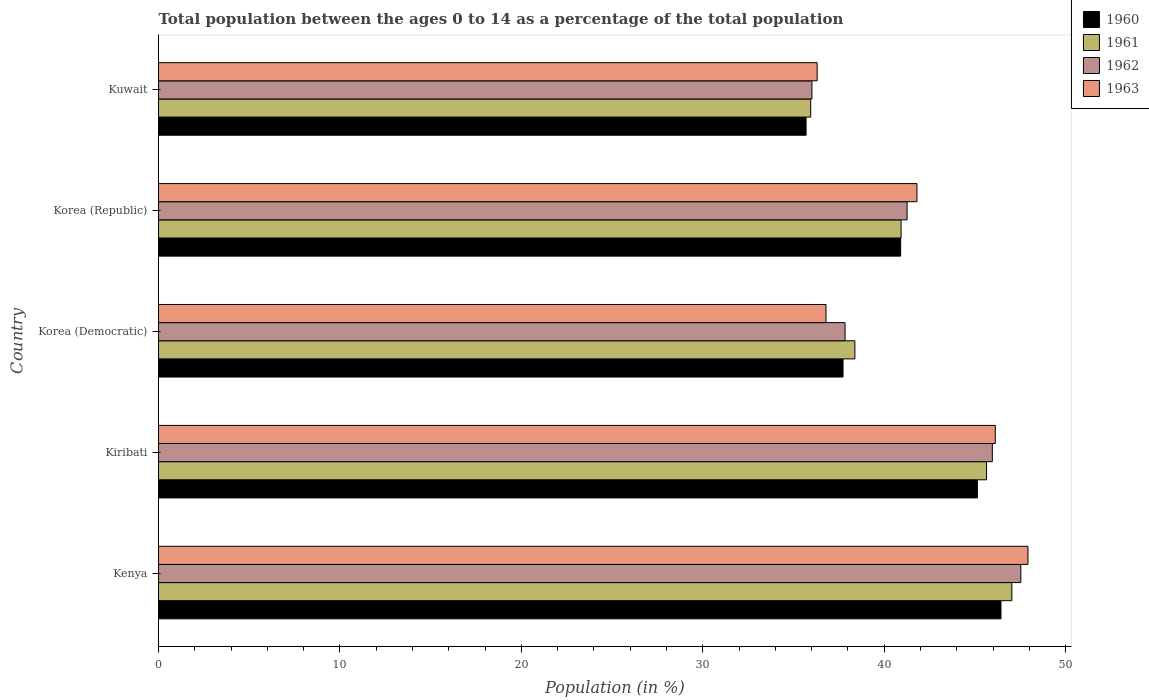How many different coloured bars are there?
Provide a succinct answer. 4. How many groups of bars are there?
Offer a very short reply. 5. How many bars are there on the 2nd tick from the bottom?
Offer a very short reply. 4. In how many cases, is the number of bars for a given country not equal to the number of legend labels?
Provide a succinct answer. 0. What is the percentage of the population ages 0 to 14 in 1961 in Kenya?
Ensure brevity in your answer.  47.04. Across all countries, what is the maximum percentage of the population ages 0 to 14 in 1962?
Give a very brief answer. 47.53. Across all countries, what is the minimum percentage of the population ages 0 to 14 in 1962?
Make the answer very short. 36.02. In which country was the percentage of the population ages 0 to 14 in 1962 maximum?
Offer a very short reply. Kenya. In which country was the percentage of the population ages 0 to 14 in 1962 minimum?
Make the answer very short. Kuwait. What is the total percentage of the population ages 0 to 14 in 1960 in the graph?
Ensure brevity in your answer.  205.91. What is the difference between the percentage of the population ages 0 to 14 in 1961 in Kenya and that in Kiribati?
Offer a very short reply. 1.39. What is the difference between the percentage of the population ages 0 to 14 in 1963 in Korea (Republic) and the percentage of the population ages 0 to 14 in 1961 in Kiribati?
Ensure brevity in your answer.  -3.84. What is the average percentage of the population ages 0 to 14 in 1962 per country?
Your answer should be very brief. 41.72. What is the difference between the percentage of the population ages 0 to 14 in 1960 and percentage of the population ages 0 to 14 in 1961 in Kiribati?
Offer a very short reply. -0.51. In how many countries, is the percentage of the population ages 0 to 14 in 1963 greater than 34 ?
Your answer should be compact. 5. What is the ratio of the percentage of the population ages 0 to 14 in 1961 in Korea (Democratic) to that in Korea (Republic)?
Ensure brevity in your answer.  0.94. Is the difference between the percentage of the population ages 0 to 14 in 1960 in Korea (Republic) and Kuwait greater than the difference between the percentage of the population ages 0 to 14 in 1961 in Korea (Republic) and Kuwait?
Provide a short and direct response. Yes. What is the difference between the highest and the second highest percentage of the population ages 0 to 14 in 1963?
Provide a succinct answer. 1.8. What is the difference between the highest and the lowest percentage of the population ages 0 to 14 in 1960?
Keep it short and to the point. 10.74. In how many countries, is the percentage of the population ages 0 to 14 in 1963 greater than the average percentage of the population ages 0 to 14 in 1963 taken over all countries?
Offer a very short reply. 3. Is the sum of the percentage of the population ages 0 to 14 in 1960 in Kenya and Korea (Republic) greater than the maximum percentage of the population ages 0 to 14 in 1963 across all countries?
Your response must be concise. Yes. Is it the case that in every country, the sum of the percentage of the population ages 0 to 14 in 1961 and percentage of the population ages 0 to 14 in 1960 is greater than the sum of percentage of the population ages 0 to 14 in 1962 and percentage of the population ages 0 to 14 in 1963?
Offer a very short reply. No. What does the 2nd bar from the top in Kiribati represents?
Offer a terse response. 1962. Is it the case that in every country, the sum of the percentage of the population ages 0 to 14 in 1960 and percentage of the population ages 0 to 14 in 1961 is greater than the percentage of the population ages 0 to 14 in 1963?
Offer a terse response. Yes. Are all the bars in the graph horizontal?
Make the answer very short. Yes. How many countries are there in the graph?
Keep it short and to the point. 5. What is the difference between two consecutive major ticks on the X-axis?
Your response must be concise. 10. Does the graph contain any zero values?
Your answer should be compact. No. Does the graph contain grids?
Offer a very short reply. No. Where does the legend appear in the graph?
Provide a succinct answer. Top right. What is the title of the graph?
Keep it short and to the point. Total population between the ages 0 to 14 as a percentage of the total population. What is the label or title of the X-axis?
Your answer should be compact. Population (in %). What is the label or title of the Y-axis?
Offer a very short reply. Country. What is the Population (in %) of 1960 in Kenya?
Your response must be concise. 46.44. What is the Population (in %) of 1961 in Kenya?
Make the answer very short. 47.04. What is the Population (in %) of 1962 in Kenya?
Make the answer very short. 47.53. What is the Population (in %) in 1963 in Kenya?
Keep it short and to the point. 47.93. What is the Population (in %) of 1960 in Kiribati?
Your response must be concise. 45.14. What is the Population (in %) of 1961 in Kiribati?
Provide a short and direct response. 45.64. What is the Population (in %) of 1962 in Kiribati?
Give a very brief answer. 45.96. What is the Population (in %) in 1963 in Kiribati?
Your answer should be very brief. 46.12. What is the Population (in %) in 1960 in Korea (Democratic)?
Give a very brief answer. 37.73. What is the Population (in %) in 1961 in Korea (Democratic)?
Keep it short and to the point. 38.39. What is the Population (in %) in 1962 in Korea (Democratic)?
Offer a very short reply. 37.84. What is the Population (in %) of 1963 in Korea (Democratic)?
Ensure brevity in your answer.  36.79. What is the Population (in %) of 1960 in Korea (Republic)?
Your answer should be compact. 40.91. What is the Population (in %) of 1961 in Korea (Republic)?
Keep it short and to the point. 40.93. What is the Population (in %) in 1962 in Korea (Republic)?
Your response must be concise. 41.26. What is the Population (in %) of 1963 in Korea (Republic)?
Provide a succinct answer. 41.81. What is the Population (in %) of 1960 in Kuwait?
Offer a very short reply. 35.7. What is the Population (in %) of 1961 in Kuwait?
Your answer should be very brief. 35.95. What is the Population (in %) of 1962 in Kuwait?
Your response must be concise. 36.02. What is the Population (in %) of 1963 in Kuwait?
Make the answer very short. 36.31. Across all countries, what is the maximum Population (in %) in 1960?
Ensure brevity in your answer.  46.44. Across all countries, what is the maximum Population (in %) in 1961?
Ensure brevity in your answer.  47.04. Across all countries, what is the maximum Population (in %) of 1962?
Offer a terse response. 47.53. Across all countries, what is the maximum Population (in %) of 1963?
Ensure brevity in your answer.  47.93. Across all countries, what is the minimum Population (in %) in 1960?
Offer a very short reply. 35.7. Across all countries, what is the minimum Population (in %) of 1961?
Provide a succinct answer. 35.95. Across all countries, what is the minimum Population (in %) of 1962?
Keep it short and to the point. 36.02. Across all countries, what is the minimum Population (in %) of 1963?
Your response must be concise. 36.31. What is the total Population (in %) in 1960 in the graph?
Keep it short and to the point. 205.91. What is the total Population (in %) of 1961 in the graph?
Ensure brevity in your answer.  207.95. What is the total Population (in %) of 1962 in the graph?
Ensure brevity in your answer.  208.62. What is the total Population (in %) of 1963 in the graph?
Keep it short and to the point. 208.95. What is the difference between the Population (in %) in 1960 in Kenya and that in Kiribati?
Your answer should be very brief. 1.3. What is the difference between the Population (in %) in 1961 in Kenya and that in Kiribati?
Your answer should be very brief. 1.39. What is the difference between the Population (in %) in 1962 in Kenya and that in Kiribati?
Ensure brevity in your answer.  1.57. What is the difference between the Population (in %) of 1963 in Kenya and that in Kiribati?
Your answer should be very brief. 1.8. What is the difference between the Population (in %) in 1960 in Kenya and that in Korea (Democratic)?
Your answer should be very brief. 8.71. What is the difference between the Population (in %) in 1961 in Kenya and that in Korea (Democratic)?
Offer a very short reply. 8.65. What is the difference between the Population (in %) in 1962 in Kenya and that in Korea (Democratic)?
Provide a short and direct response. 9.69. What is the difference between the Population (in %) in 1963 in Kenya and that in Korea (Democratic)?
Your answer should be compact. 11.13. What is the difference between the Population (in %) in 1960 in Kenya and that in Korea (Republic)?
Give a very brief answer. 5.53. What is the difference between the Population (in %) of 1961 in Kenya and that in Korea (Republic)?
Make the answer very short. 6.1. What is the difference between the Population (in %) of 1962 in Kenya and that in Korea (Republic)?
Offer a terse response. 6.27. What is the difference between the Population (in %) in 1963 in Kenya and that in Korea (Republic)?
Ensure brevity in your answer.  6.12. What is the difference between the Population (in %) in 1960 in Kenya and that in Kuwait?
Offer a very short reply. 10.74. What is the difference between the Population (in %) of 1961 in Kenya and that in Kuwait?
Provide a succinct answer. 11.09. What is the difference between the Population (in %) in 1962 in Kenya and that in Kuwait?
Your answer should be compact. 11.52. What is the difference between the Population (in %) of 1963 in Kenya and that in Kuwait?
Your answer should be very brief. 11.62. What is the difference between the Population (in %) of 1960 in Kiribati and that in Korea (Democratic)?
Offer a very short reply. 7.4. What is the difference between the Population (in %) in 1961 in Kiribati and that in Korea (Democratic)?
Offer a very short reply. 7.26. What is the difference between the Population (in %) in 1962 in Kiribati and that in Korea (Democratic)?
Your answer should be compact. 8.12. What is the difference between the Population (in %) of 1963 in Kiribati and that in Korea (Democratic)?
Provide a succinct answer. 9.33. What is the difference between the Population (in %) in 1960 in Kiribati and that in Korea (Republic)?
Offer a very short reply. 4.23. What is the difference between the Population (in %) in 1961 in Kiribati and that in Korea (Republic)?
Your response must be concise. 4.71. What is the difference between the Population (in %) in 1962 in Kiribati and that in Korea (Republic)?
Make the answer very short. 4.7. What is the difference between the Population (in %) in 1963 in Kiribati and that in Korea (Republic)?
Provide a succinct answer. 4.32. What is the difference between the Population (in %) of 1960 in Kiribati and that in Kuwait?
Your answer should be very brief. 9.44. What is the difference between the Population (in %) of 1961 in Kiribati and that in Kuwait?
Offer a very short reply. 9.69. What is the difference between the Population (in %) of 1962 in Kiribati and that in Kuwait?
Your response must be concise. 9.94. What is the difference between the Population (in %) in 1963 in Kiribati and that in Kuwait?
Provide a short and direct response. 9.82. What is the difference between the Population (in %) in 1960 in Korea (Democratic) and that in Korea (Republic)?
Your answer should be compact. -3.17. What is the difference between the Population (in %) of 1961 in Korea (Democratic) and that in Korea (Republic)?
Your response must be concise. -2.55. What is the difference between the Population (in %) of 1962 in Korea (Democratic) and that in Korea (Republic)?
Your response must be concise. -3.42. What is the difference between the Population (in %) of 1963 in Korea (Democratic) and that in Korea (Republic)?
Provide a short and direct response. -5.01. What is the difference between the Population (in %) of 1960 in Korea (Democratic) and that in Kuwait?
Provide a short and direct response. 2.04. What is the difference between the Population (in %) in 1961 in Korea (Democratic) and that in Kuwait?
Your response must be concise. 2.44. What is the difference between the Population (in %) in 1962 in Korea (Democratic) and that in Kuwait?
Your answer should be very brief. 1.83. What is the difference between the Population (in %) in 1963 in Korea (Democratic) and that in Kuwait?
Give a very brief answer. 0.49. What is the difference between the Population (in %) of 1960 in Korea (Republic) and that in Kuwait?
Give a very brief answer. 5.21. What is the difference between the Population (in %) in 1961 in Korea (Republic) and that in Kuwait?
Your answer should be very brief. 4.98. What is the difference between the Population (in %) of 1962 in Korea (Republic) and that in Kuwait?
Provide a short and direct response. 5.25. What is the difference between the Population (in %) in 1963 in Korea (Republic) and that in Kuwait?
Give a very brief answer. 5.5. What is the difference between the Population (in %) in 1960 in Kenya and the Population (in %) in 1961 in Kiribati?
Offer a terse response. 0.8. What is the difference between the Population (in %) of 1960 in Kenya and the Population (in %) of 1962 in Kiribati?
Provide a succinct answer. 0.48. What is the difference between the Population (in %) in 1960 in Kenya and the Population (in %) in 1963 in Kiribati?
Keep it short and to the point. 0.31. What is the difference between the Population (in %) in 1961 in Kenya and the Population (in %) in 1962 in Kiribati?
Keep it short and to the point. 1.07. What is the difference between the Population (in %) of 1961 in Kenya and the Population (in %) of 1963 in Kiribati?
Your answer should be compact. 0.91. What is the difference between the Population (in %) in 1962 in Kenya and the Population (in %) in 1963 in Kiribati?
Provide a succinct answer. 1.41. What is the difference between the Population (in %) in 1960 in Kenya and the Population (in %) in 1961 in Korea (Democratic)?
Provide a short and direct response. 8.05. What is the difference between the Population (in %) in 1960 in Kenya and the Population (in %) in 1962 in Korea (Democratic)?
Make the answer very short. 8.6. What is the difference between the Population (in %) of 1960 in Kenya and the Population (in %) of 1963 in Korea (Democratic)?
Offer a very short reply. 9.65. What is the difference between the Population (in %) in 1961 in Kenya and the Population (in %) in 1962 in Korea (Democratic)?
Make the answer very short. 9.19. What is the difference between the Population (in %) in 1961 in Kenya and the Population (in %) in 1963 in Korea (Democratic)?
Provide a short and direct response. 10.24. What is the difference between the Population (in %) in 1962 in Kenya and the Population (in %) in 1963 in Korea (Democratic)?
Your answer should be very brief. 10.74. What is the difference between the Population (in %) in 1960 in Kenya and the Population (in %) in 1961 in Korea (Republic)?
Provide a succinct answer. 5.51. What is the difference between the Population (in %) of 1960 in Kenya and the Population (in %) of 1962 in Korea (Republic)?
Your answer should be compact. 5.18. What is the difference between the Population (in %) of 1960 in Kenya and the Population (in %) of 1963 in Korea (Republic)?
Offer a terse response. 4.63. What is the difference between the Population (in %) of 1961 in Kenya and the Population (in %) of 1962 in Korea (Republic)?
Keep it short and to the point. 5.77. What is the difference between the Population (in %) in 1961 in Kenya and the Population (in %) in 1963 in Korea (Republic)?
Your response must be concise. 5.23. What is the difference between the Population (in %) of 1962 in Kenya and the Population (in %) of 1963 in Korea (Republic)?
Provide a short and direct response. 5.73. What is the difference between the Population (in %) of 1960 in Kenya and the Population (in %) of 1961 in Kuwait?
Your answer should be very brief. 10.49. What is the difference between the Population (in %) of 1960 in Kenya and the Population (in %) of 1962 in Kuwait?
Your answer should be compact. 10.42. What is the difference between the Population (in %) in 1960 in Kenya and the Population (in %) in 1963 in Kuwait?
Keep it short and to the point. 10.13. What is the difference between the Population (in %) of 1961 in Kenya and the Population (in %) of 1962 in Kuwait?
Offer a very short reply. 11.02. What is the difference between the Population (in %) in 1961 in Kenya and the Population (in %) in 1963 in Kuwait?
Make the answer very short. 10.73. What is the difference between the Population (in %) in 1962 in Kenya and the Population (in %) in 1963 in Kuwait?
Your answer should be very brief. 11.23. What is the difference between the Population (in %) in 1960 in Kiribati and the Population (in %) in 1961 in Korea (Democratic)?
Give a very brief answer. 6.75. What is the difference between the Population (in %) of 1960 in Kiribati and the Population (in %) of 1962 in Korea (Democratic)?
Ensure brevity in your answer.  7.29. What is the difference between the Population (in %) of 1960 in Kiribati and the Population (in %) of 1963 in Korea (Democratic)?
Keep it short and to the point. 8.34. What is the difference between the Population (in %) of 1961 in Kiribati and the Population (in %) of 1962 in Korea (Democratic)?
Your answer should be compact. 7.8. What is the difference between the Population (in %) in 1961 in Kiribati and the Population (in %) in 1963 in Korea (Democratic)?
Provide a succinct answer. 8.85. What is the difference between the Population (in %) of 1962 in Kiribati and the Population (in %) of 1963 in Korea (Democratic)?
Provide a short and direct response. 9.17. What is the difference between the Population (in %) in 1960 in Kiribati and the Population (in %) in 1961 in Korea (Republic)?
Give a very brief answer. 4.21. What is the difference between the Population (in %) in 1960 in Kiribati and the Population (in %) in 1962 in Korea (Republic)?
Offer a very short reply. 3.87. What is the difference between the Population (in %) in 1960 in Kiribati and the Population (in %) in 1963 in Korea (Republic)?
Provide a succinct answer. 3.33. What is the difference between the Population (in %) in 1961 in Kiribati and the Population (in %) in 1962 in Korea (Republic)?
Your answer should be very brief. 4.38. What is the difference between the Population (in %) in 1961 in Kiribati and the Population (in %) in 1963 in Korea (Republic)?
Keep it short and to the point. 3.84. What is the difference between the Population (in %) in 1962 in Kiribati and the Population (in %) in 1963 in Korea (Republic)?
Offer a very short reply. 4.15. What is the difference between the Population (in %) in 1960 in Kiribati and the Population (in %) in 1961 in Kuwait?
Offer a terse response. 9.19. What is the difference between the Population (in %) of 1960 in Kiribati and the Population (in %) of 1962 in Kuwait?
Offer a very short reply. 9.12. What is the difference between the Population (in %) in 1960 in Kiribati and the Population (in %) in 1963 in Kuwait?
Ensure brevity in your answer.  8.83. What is the difference between the Population (in %) of 1961 in Kiribati and the Population (in %) of 1962 in Kuwait?
Provide a short and direct response. 9.63. What is the difference between the Population (in %) of 1961 in Kiribati and the Population (in %) of 1963 in Kuwait?
Keep it short and to the point. 9.34. What is the difference between the Population (in %) of 1962 in Kiribati and the Population (in %) of 1963 in Kuwait?
Your answer should be compact. 9.66. What is the difference between the Population (in %) of 1960 in Korea (Democratic) and the Population (in %) of 1961 in Korea (Republic)?
Make the answer very short. -3.2. What is the difference between the Population (in %) of 1960 in Korea (Democratic) and the Population (in %) of 1962 in Korea (Republic)?
Your response must be concise. -3.53. What is the difference between the Population (in %) of 1960 in Korea (Democratic) and the Population (in %) of 1963 in Korea (Republic)?
Your answer should be compact. -4.07. What is the difference between the Population (in %) of 1961 in Korea (Democratic) and the Population (in %) of 1962 in Korea (Republic)?
Provide a short and direct response. -2.88. What is the difference between the Population (in %) in 1961 in Korea (Democratic) and the Population (in %) in 1963 in Korea (Republic)?
Keep it short and to the point. -3.42. What is the difference between the Population (in %) of 1962 in Korea (Democratic) and the Population (in %) of 1963 in Korea (Republic)?
Your answer should be very brief. -3.96. What is the difference between the Population (in %) of 1960 in Korea (Democratic) and the Population (in %) of 1961 in Kuwait?
Make the answer very short. 1.78. What is the difference between the Population (in %) in 1960 in Korea (Democratic) and the Population (in %) in 1962 in Kuwait?
Provide a short and direct response. 1.72. What is the difference between the Population (in %) of 1960 in Korea (Democratic) and the Population (in %) of 1963 in Kuwait?
Your answer should be very brief. 1.43. What is the difference between the Population (in %) of 1961 in Korea (Democratic) and the Population (in %) of 1962 in Kuwait?
Offer a terse response. 2.37. What is the difference between the Population (in %) of 1961 in Korea (Democratic) and the Population (in %) of 1963 in Kuwait?
Provide a short and direct response. 2.08. What is the difference between the Population (in %) in 1962 in Korea (Democratic) and the Population (in %) in 1963 in Kuwait?
Make the answer very short. 1.54. What is the difference between the Population (in %) in 1960 in Korea (Republic) and the Population (in %) in 1961 in Kuwait?
Your answer should be compact. 4.96. What is the difference between the Population (in %) of 1960 in Korea (Republic) and the Population (in %) of 1962 in Kuwait?
Provide a succinct answer. 4.89. What is the difference between the Population (in %) of 1960 in Korea (Republic) and the Population (in %) of 1963 in Kuwait?
Your answer should be very brief. 4.6. What is the difference between the Population (in %) in 1961 in Korea (Republic) and the Population (in %) in 1962 in Kuwait?
Offer a very short reply. 4.92. What is the difference between the Population (in %) in 1961 in Korea (Republic) and the Population (in %) in 1963 in Kuwait?
Make the answer very short. 4.63. What is the difference between the Population (in %) in 1962 in Korea (Republic) and the Population (in %) in 1963 in Kuwait?
Your answer should be very brief. 4.96. What is the average Population (in %) of 1960 per country?
Make the answer very short. 41.18. What is the average Population (in %) of 1961 per country?
Offer a very short reply. 41.59. What is the average Population (in %) of 1962 per country?
Make the answer very short. 41.72. What is the average Population (in %) in 1963 per country?
Provide a short and direct response. 41.79. What is the difference between the Population (in %) in 1960 and Population (in %) in 1961 in Kenya?
Keep it short and to the point. -0.6. What is the difference between the Population (in %) in 1960 and Population (in %) in 1962 in Kenya?
Offer a very short reply. -1.09. What is the difference between the Population (in %) in 1960 and Population (in %) in 1963 in Kenya?
Offer a very short reply. -1.49. What is the difference between the Population (in %) of 1961 and Population (in %) of 1962 in Kenya?
Offer a terse response. -0.5. What is the difference between the Population (in %) of 1961 and Population (in %) of 1963 in Kenya?
Give a very brief answer. -0.89. What is the difference between the Population (in %) of 1962 and Population (in %) of 1963 in Kenya?
Your response must be concise. -0.39. What is the difference between the Population (in %) in 1960 and Population (in %) in 1961 in Kiribati?
Your answer should be compact. -0.51. What is the difference between the Population (in %) of 1960 and Population (in %) of 1962 in Kiribati?
Your answer should be compact. -0.82. What is the difference between the Population (in %) of 1960 and Population (in %) of 1963 in Kiribati?
Ensure brevity in your answer.  -0.99. What is the difference between the Population (in %) of 1961 and Population (in %) of 1962 in Kiribati?
Offer a very short reply. -0.32. What is the difference between the Population (in %) of 1961 and Population (in %) of 1963 in Kiribati?
Make the answer very short. -0.48. What is the difference between the Population (in %) in 1962 and Population (in %) in 1963 in Kiribati?
Ensure brevity in your answer.  -0.16. What is the difference between the Population (in %) of 1960 and Population (in %) of 1961 in Korea (Democratic)?
Provide a succinct answer. -0.65. What is the difference between the Population (in %) in 1960 and Population (in %) in 1962 in Korea (Democratic)?
Make the answer very short. -0.11. What is the difference between the Population (in %) in 1960 and Population (in %) in 1963 in Korea (Democratic)?
Ensure brevity in your answer.  0.94. What is the difference between the Population (in %) of 1961 and Population (in %) of 1962 in Korea (Democratic)?
Ensure brevity in your answer.  0.54. What is the difference between the Population (in %) in 1961 and Population (in %) in 1963 in Korea (Democratic)?
Make the answer very short. 1.59. What is the difference between the Population (in %) of 1962 and Population (in %) of 1963 in Korea (Democratic)?
Offer a terse response. 1.05. What is the difference between the Population (in %) in 1960 and Population (in %) in 1961 in Korea (Republic)?
Your answer should be compact. -0.02. What is the difference between the Population (in %) of 1960 and Population (in %) of 1962 in Korea (Republic)?
Your answer should be very brief. -0.36. What is the difference between the Population (in %) in 1960 and Population (in %) in 1963 in Korea (Republic)?
Offer a very short reply. -0.9. What is the difference between the Population (in %) in 1961 and Population (in %) in 1962 in Korea (Republic)?
Offer a very short reply. -0.33. What is the difference between the Population (in %) of 1961 and Population (in %) of 1963 in Korea (Republic)?
Make the answer very short. -0.88. What is the difference between the Population (in %) of 1962 and Population (in %) of 1963 in Korea (Republic)?
Your answer should be compact. -0.54. What is the difference between the Population (in %) of 1960 and Population (in %) of 1961 in Kuwait?
Make the answer very short. -0.25. What is the difference between the Population (in %) of 1960 and Population (in %) of 1962 in Kuwait?
Keep it short and to the point. -0.32. What is the difference between the Population (in %) in 1960 and Population (in %) in 1963 in Kuwait?
Offer a terse response. -0.61. What is the difference between the Population (in %) of 1961 and Population (in %) of 1962 in Kuwait?
Offer a terse response. -0.07. What is the difference between the Population (in %) of 1961 and Population (in %) of 1963 in Kuwait?
Provide a short and direct response. -0.36. What is the difference between the Population (in %) in 1962 and Population (in %) in 1963 in Kuwait?
Provide a succinct answer. -0.29. What is the ratio of the Population (in %) in 1960 in Kenya to that in Kiribati?
Provide a succinct answer. 1.03. What is the ratio of the Population (in %) in 1961 in Kenya to that in Kiribati?
Your answer should be very brief. 1.03. What is the ratio of the Population (in %) of 1962 in Kenya to that in Kiribati?
Provide a short and direct response. 1.03. What is the ratio of the Population (in %) of 1963 in Kenya to that in Kiribati?
Give a very brief answer. 1.04. What is the ratio of the Population (in %) in 1960 in Kenya to that in Korea (Democratic)?
Your answer should be compact. 1.23. What is the ratio of the Population (in %) of 1961 in Kenya to that in Korea (Democratic)?
Your response must be concise. 1.23. What is the ratio of the Population (in %) of 1962 in Kenya to that in Korea (Democratic)?
Provide a succinct answer. 1.26. What is the ratio of the Population (in %) of 1963 in Kenya to that in Korea (Democratic)?
Provide a succinct answer. 1.3. What is the ratio of the Population (in %) in 1960 in Kenya to that in Korea (Republic)?
Make the answer very short. 1.14. What is the ratio of the Population (in %) of 1961 in Kenya to that in Korea (Republic)?
Give a very brief answer. 1.15. What is the ratio of the Population (in %) in 1962 in Kenya to that in Korea (Republic)?
Your response must be concise. 1.15. What is the ratio of the Population (in %) in 1963 in Kenya to that in Korea (Republic)?
Your answer should be very brief. 1.15. What is the ratio of the Population (in %) in 1960 in Kenya to that in Kuwait?
Your answer should be compact. 1.3. What is the ratio of the Population (in %) of 1961 in Kenya to that in Kuwait?
Offer a very short reply. 1.31. What is the ratio of the Population (in %) in 1962 in Kenya to that in Kuwait?
Offer a terse response. 1.32. What is the ratio of the Population (in %) in 1963 in Kenya to that in Kuwait?
Your response must be concise. 1.32. What is the ratio of the Population (in %) in 1960 in Kiribati to that in Korea (Democratic)?
Your answer should be compact. 1.2. What is the ratio of the Population (in %) in 1961 in Kiribati to that in Korea (Democratic)?
Offer a terse response. 1.19. What is the ratio of the Population (in %) in 1962 in Kiribati to that in Korea (Democratic)?
Your answer should be compact. 1.21. What is the ratio of the Population (in %) of 1963 in Kiribati to that in Korea (Democratic)?
Provide a short and direct response. 1.25. What is the ratio of the Population (in %) of 1960 in Kiribati to that in Korea (Republic)?
Make the answer very short. 1.1. What is the ratio of the Population (in %) of 1961 in Kiribati to that in Korea (Republic)?
Make the answer very short. 1.12. What is the ratio of the Population (in %) in 1962 in Kiribati to that in Korea (Republic)?
Your answer should be compact. 1.11. What is the ratio of the Population (in %) in 1963 in Kiribati to that in Korea (Republic)?
Your response must be concise. 1.1. What is the ratio of the Population (in %) in 1960 in Kiribati to that in Kuwait?
Provide a succinct answer. 1.26. What is the ratio of the Population (in %) in 1961 in Kiribati to that in Kuwait?
Provide a short and direct response. 1.27. What is the ratio of the Population (in %) in 1962 in Kiribati to that in Kuwait?
Offer a terse response. 1.28. What is the ratio of the Population (in %) of 1963 in Kiribati to that in Kuwait?
Give a very brief answer. 1.27. What is the ratio of the Population (in %) in 1960 in Korea (Democratic) to that in Korea (Republic)?
Give a very brief answer. 0.92. What is the ratio of the Population (in %) in 1961 in Korea (Democratic) to that in Korea (Republic)?
Offer a very short reply. 0.94. What is the ratio of the Population (in %) of 1962 in Korea (Democratic) to that in Korea (Republic)?
Provide a succinct answer. 0.92. What is the ratio of the Population (in %) of 1963 in Korea (Democratic) to that in Korea (Republic)?
Provide a short and direct response. 0.88. What is the ratio of the Population (in %) in 1960 in Korea (Democratic) to that in Kuwait?
Provide a succinct answer. 1.06. What is the ratio of the Population (in %) in 1961 in Korea (Democratic) to that in Kuwait?
Ensure brevity in your answer.  1.07. What is the ratio of the Population (in %) of 1962 in Korea (Democratic) to that in Kuwait?
Ensure brevity in your answer.  1.05. What is the ratio of the Population (in %) in 1963 in Korea (Democratic) to that in Kuwait?
Offer a terse response. 1.01. What is the ratio of the Population (in %) in 1960 in Korea (Republic) to that in Kuwait?
Your answer should be compact. 1.15. What is the ratio of the Population (in %) of 1961 in Korea (Republic) to that in Kuwait?
Make the answer very short. 1.14. What is the ratio of the Population (in %) in 1962 in Korea (Republic) to that in Kuwait?
Your answer should be compact. 1.15. What is the ratio of the Population (in %) in 1963 in Korea (Republic) to that in Kuwait?
Your answer should be compact. 1.15. What is the difference between the highest and the second highest Population (in %) in 1960?
Your answer should be very brief. 1.3. What is the difference between the highest and the second highest Population (in %) of 1961?
Offer a very short reply. 1.39. What is the difference between the highest and the second highest Population (in %) of 1962?
Your answer should be very brief. 1.57. What is the difference between the highest and the second highest Population (in %) in 1963?
Offer a terse response. 1.8. What is the difference between the highest and the lowest Population (in %) of 1960?
Give a very brief answer. 10.74. What is the difference between the highest and the lowest Population (in %) in 1961?
Give a very brief answer. 11.09. What is the difference between the highest and the lowest Population (in %) in 1962?
Your response must be concise. 11.52. What is the difference between the highest and the lowest Population (in %) in 1963?
Give a very brief answer. 11.62. 